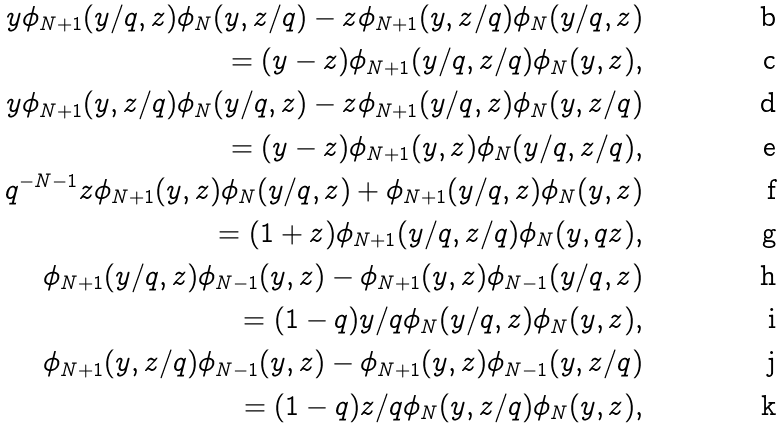<formula> <loc_0><loc_0><loc_500><loc_500>y \phi _ { N + 1 } ( y / q , z ) \phi _ { N } ( y , z / q ) - z \phi _ { N + 1 } ( y , z / q ) \phi _ { N } ( y / q , z ) \\ = ( y - z ) \phi _ { N + 1 } ( y / q , z / q ) \phi _ { N } ( y , z ) , \\ y \phi _ { N + 1 } ( y , z / q ) \phi _ { N } ( y / q , z ) - z \phi _ { N + 1 } ( y / q , z ) \phi _ { N } ( y , z / q ) \\ = ( y - z ) \phi _ { N + 1 } ( y , z ) \phi _ { N } ( y / q , z / q ) , \\ q ^ { - N - 1 } z \phi _ { N + 1 } ( y , z ) \phi _ { N } ( y / q , z ) + \phi _ { N + 1 } ( y / q , z ) \phi _ { N } ( y , z ) \\ = ( 1 + z ) \phi _ { N + 1 } ( y / q , z / q ) \phi _ { N } ( y , q z ) , \\ \phi _ { N + 1 } ( y / q , z ) \phi _ { N - 1 } ( y , z ) - \phi _ { N + 1 } ( y , z ) \phi _ { N - 1 } ( y / q , z ) \\ = ( 1 - q ) y / q \phi _ { N } ( y / q , z ) \phi _ { N } ( y , z ) , \\ \phi _ { N + 1 } ( y , z / q ) \phi _ { N - 1 } ( y , z ) - \phi _ { N + 1 } ( y , z ) \phi _ { N - 1 } ( y , z / q ) \\ = ( 1 - q ) z / q \phi _ { N } ( y , z / q ) \phi _ { N } ( y , z ) ,</formula> 